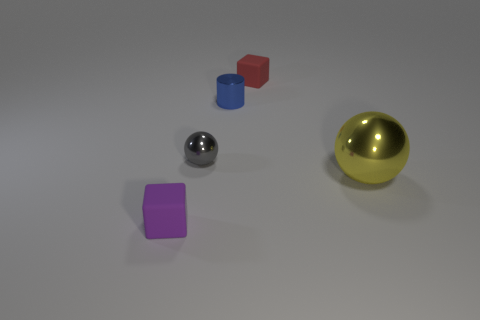There is a sphere that is made of the same material as the small gray thing; what color is it? The sphere that shares the same material as the small gray object is silver, reflecting a metallic and shiny appearance similar to that of polished metal. 